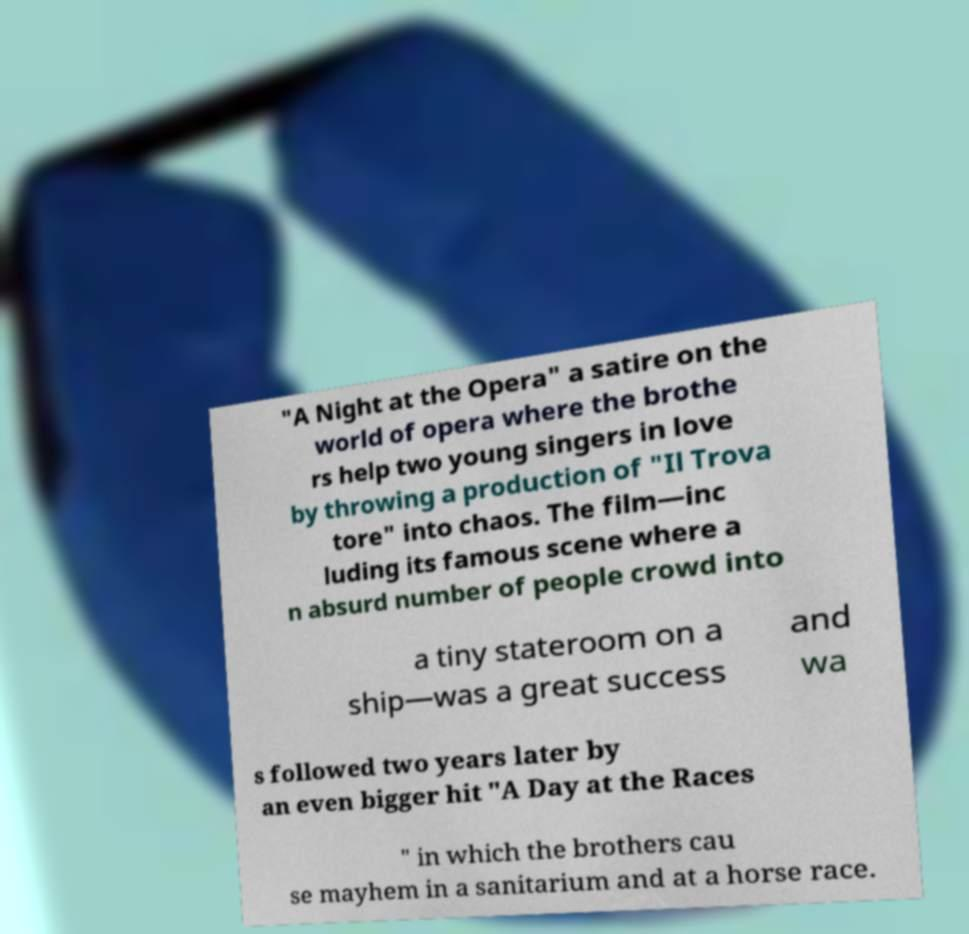I need the written content from this picture converted into text. Can you do that? "A Night at the Opera" a satire on the world of opera where the brothe rs help two young singers in love by throwing a production of "Il Trova tore" into chaos. The film—inc luding its famous scene where a n absurd number of people crowd into a tiny stateroom on a ship—was a great success and wa s followed two years later by an even bigger hit "A Day at the Races " in which the brothers cau se mayhem in a sanitarium and at a horse race. 